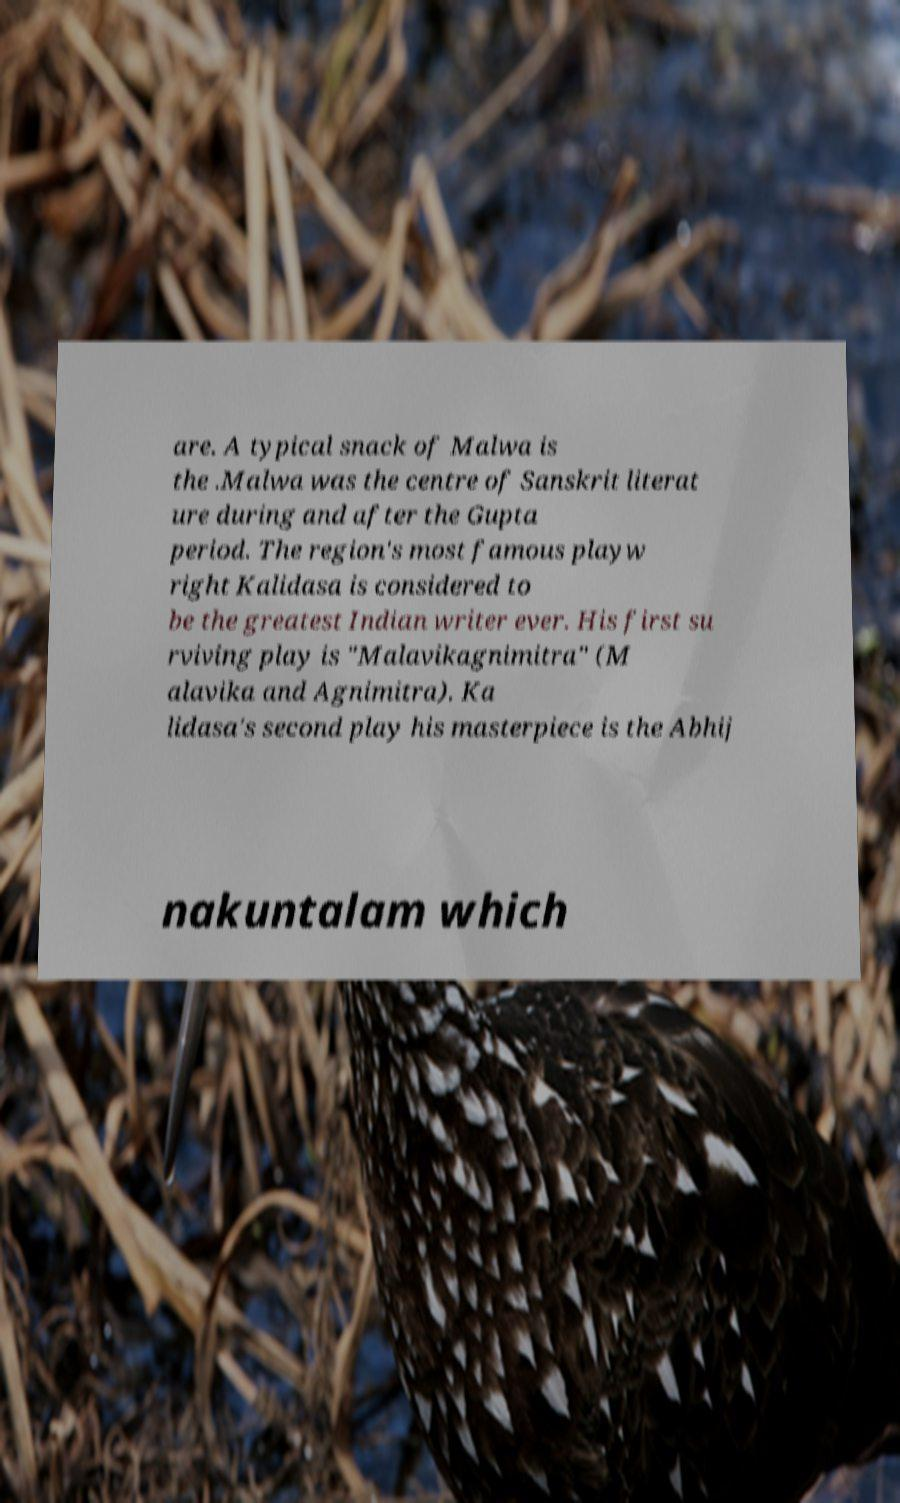Can you accurately transcribe the text from the provided image for me? are. A typical snack of Malwa is the .Malwa was the centre of Sanskrit literat ure during and after the Gupta period. The region's most famous playw right Kalidasa is considered to be the greatest Indian writer ever. His first su rviving play is "Malavikagnimitra" (M alavika and Agnimitra). Ka lidasa's second play his masterpiece is the Abhij nakuntalam which 